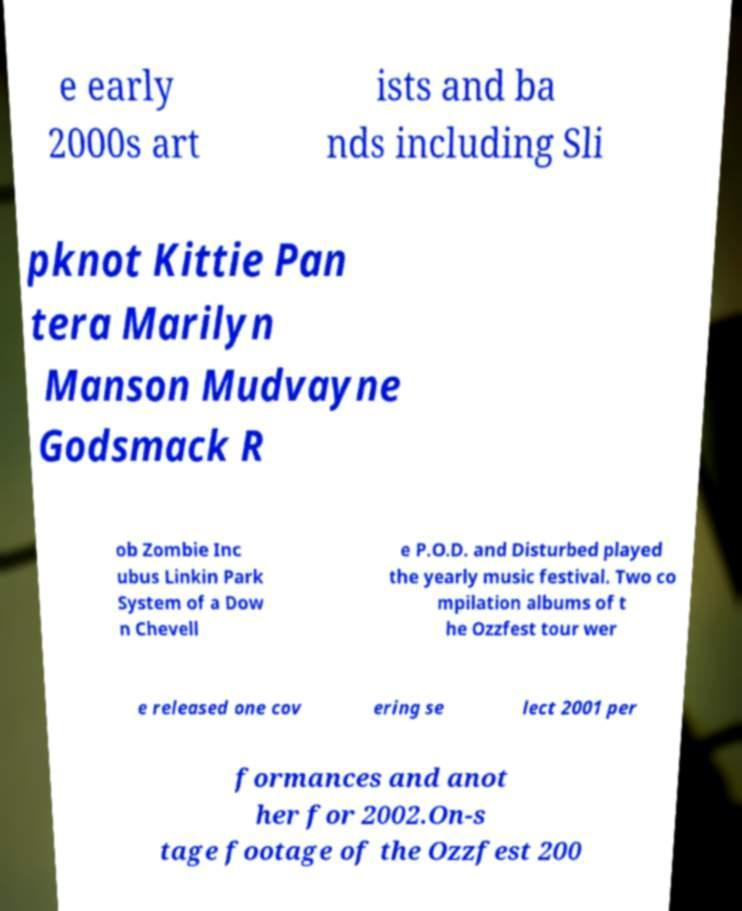There's text embedded in this image that I need extracted. Can you transcribe it verbatim? e early 2000s art ists and ba nds including Sli pknot Kittie Pan tera Marilyn Manson Mudvayne Godsmack R ob Zombie Inc ubus Linkin Park System of a Dow n Chevell e P.O.D. and Disturbed played the yearly music festival. Two co mpilation albums of t he Ozzfest tour wer e released one cov ering se lect 2001 per formances and anot her for 2002.On-s tage footage of the Ozzfest 200 